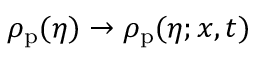<formula> <loc_0><loc_0><loc_500><loc_500>\rho _ { p } ( \eta ) \to \rho _ { p } ( \eta ; x , t )</formula> 